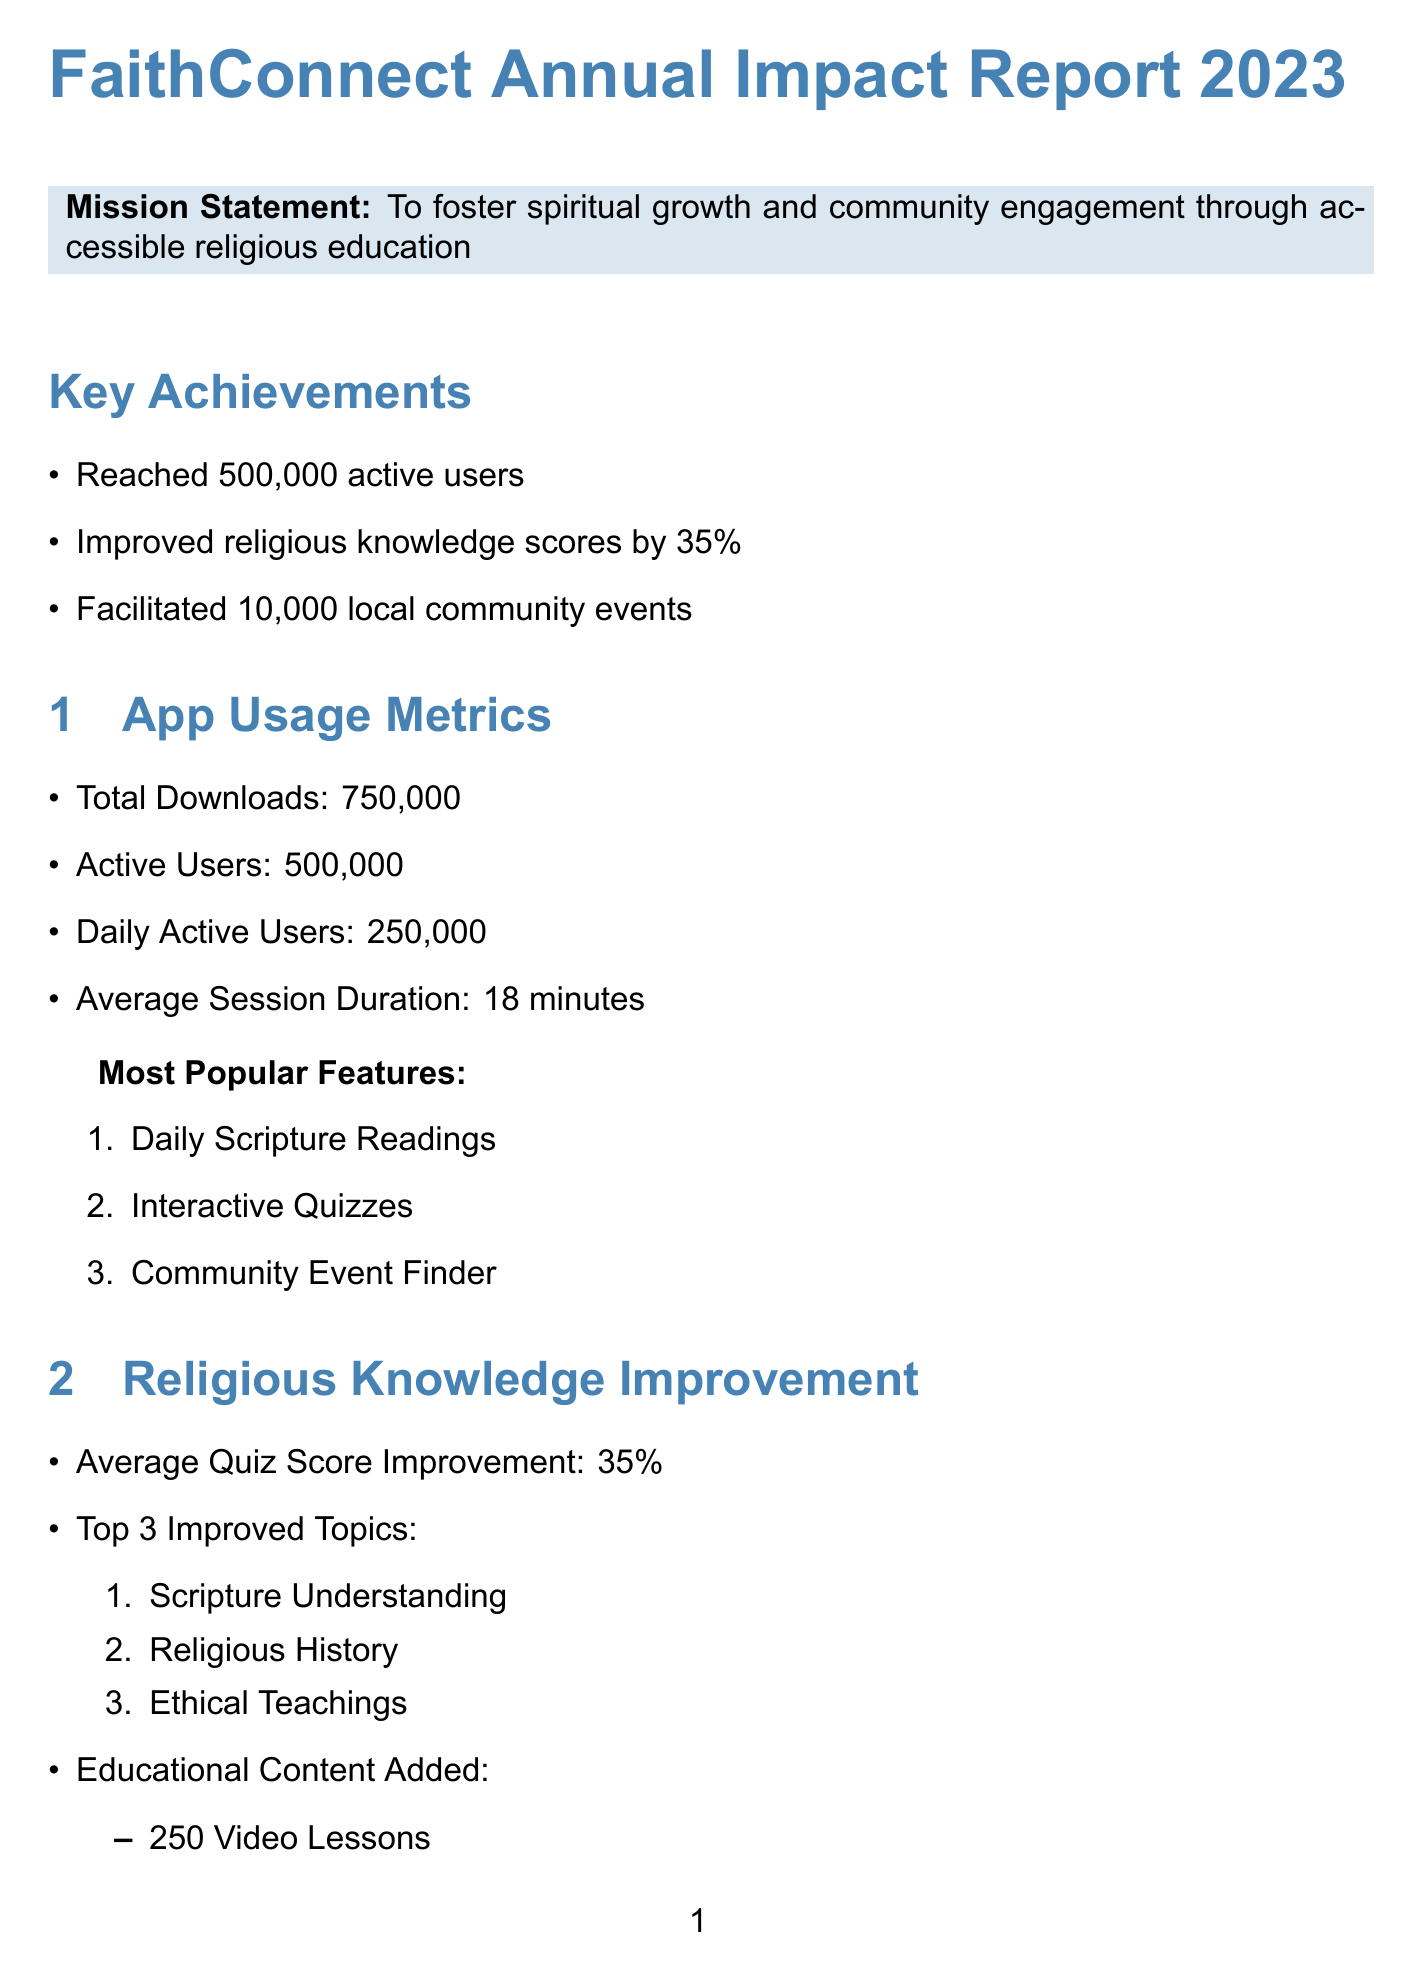What is the total number of downloads? The total downloads are explicitly stated in the app usage metrics section of the document.
Answer: 750,000 What percentage did religious knowledge improve? The average improvement in religious knowledge scores is mentioned in the religious knowledge improvement section.
Answer: 35% How many local community events were facilitated? The key achievements section lists the total number of local community events organized.
Answer: 10,000 What is the average event attendance? The average attendance for events organized is provided in the community engagement section.
Answer: 25 Name one of the top three improved topics. The document lists three topics that saw significant improvement under the religious knowledge improvement section.
Answer: Scripture Understanding What is the total revenue? The total revenue figure is presented in the financial overview section of the document.
Answer: $2,500,000 What percentage of revenue comes from donations? The document specifies the percentage of total revenue that comes from donations under the revenue sources.
Answer: 60% What is one of the future goals? The future goals section outlines several objectives for the organization, including expanding the user base.
Answer: Expand user base to 1 million active users How many volunteer hours were logged? This metric is listed in the community engagement section of the report.
Answer: 75,000 